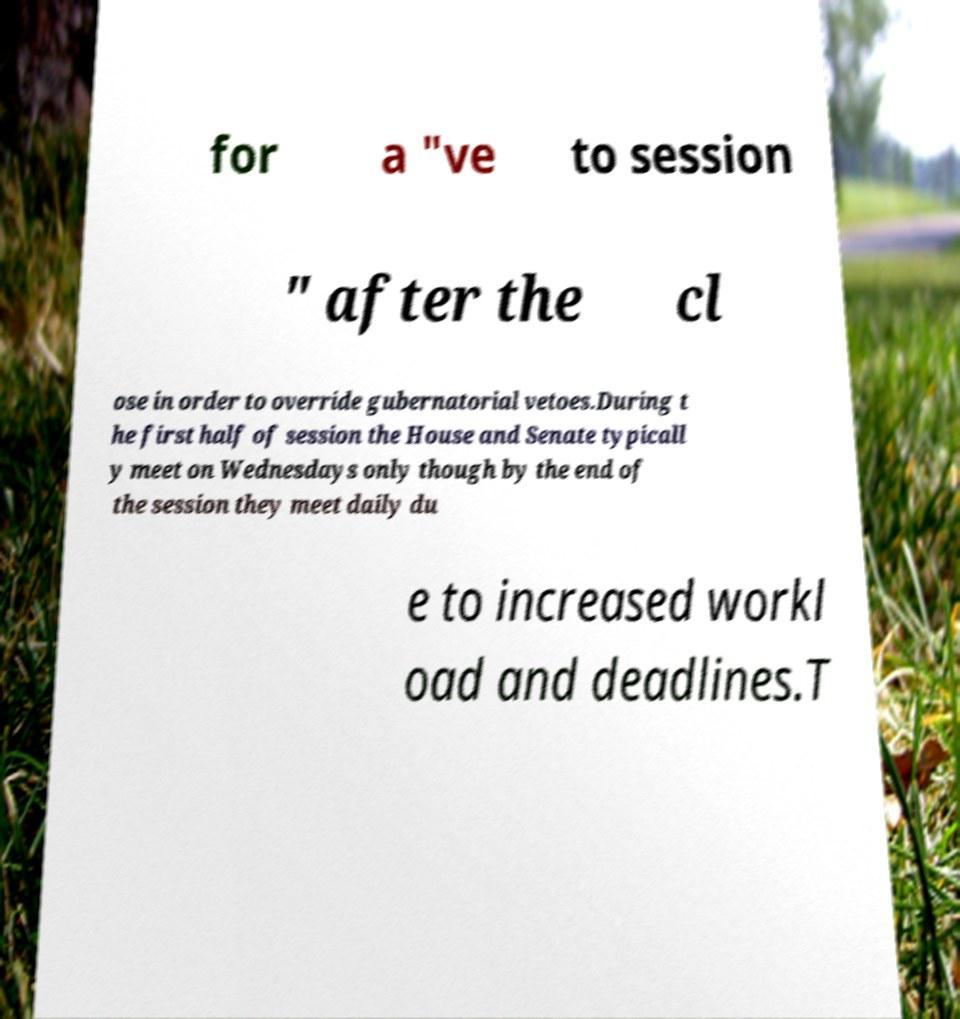I need the written content from this picture converted into text. Can you do that? for a "ve to session " after the cl ose in order to override gubernatorial vetoes.During t he first half of session the House and Senate typicall y meet on Wednesdays only though by the end of the session they meet daily du e to increased workl oad and deadlines.T 